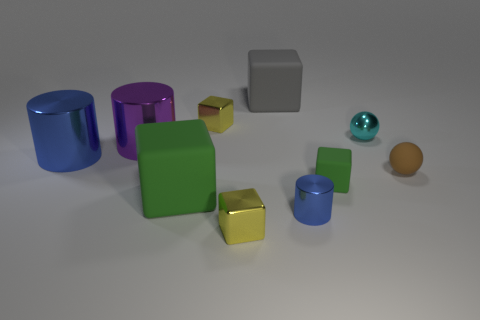How many other things are there of the same shape as the brown thing?
Your answer should be very brief. 1. There is a green matte block that is on the right side of the big matte thing that is left of the tiny cube behind the small green object; how big is it?
Offer a terse response. Small. What number of purple things are either small matte spheres or shiny balls?
Keep it short and to the point. 0. What is the shape of the blue metallic object to the left of the small metal block in front of the matte ball?
Give a very brief answer. Cylinder. Is the size of the object in front of the tiny blue cylinder the same as the yellow object that is behind the cyan shiny object?
Your response must be concise. Yes. Are there any tiny blue cylinders made of the same material as the purple cylinder?
Your response must be concise. Yes. There is another cylinder that is the same color as the small metallic cylinder; what is its size?
Your answer should be very brief. Large. Is there a yellow block in front of the yellow metal thing that is behind the tiny green block in front of the big blue cylinder?
Ensure brevity in your answer.  Yes. There is a small blue cylinder; are there any big gray matte things right of it?
Ensure brevity in your answer.  No. What number of big purple metallic things are in front of the yellow metallic cube in front of the small green rubber thing?
Provide a short and direct response. 0. 